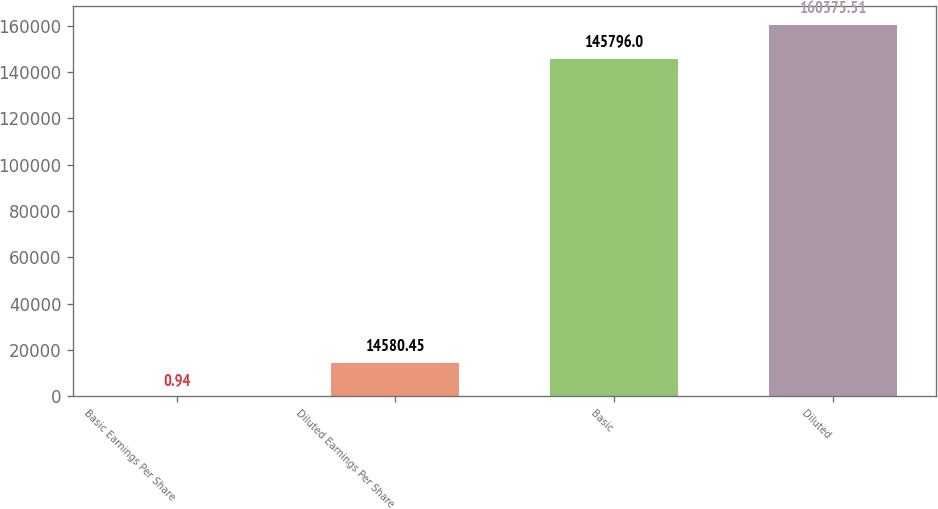<chart> <loc_0><loc_0><loc_500><loc_500><bar_chart><fcel>Basic Earnings Per Share<fcel>Diluted Earnings Per Share<fcel>Basic<fcel>Diluted<nl><fcel>0.94<fcel>14580.5<fcel>145796<fcel>160376<nl></chart> 